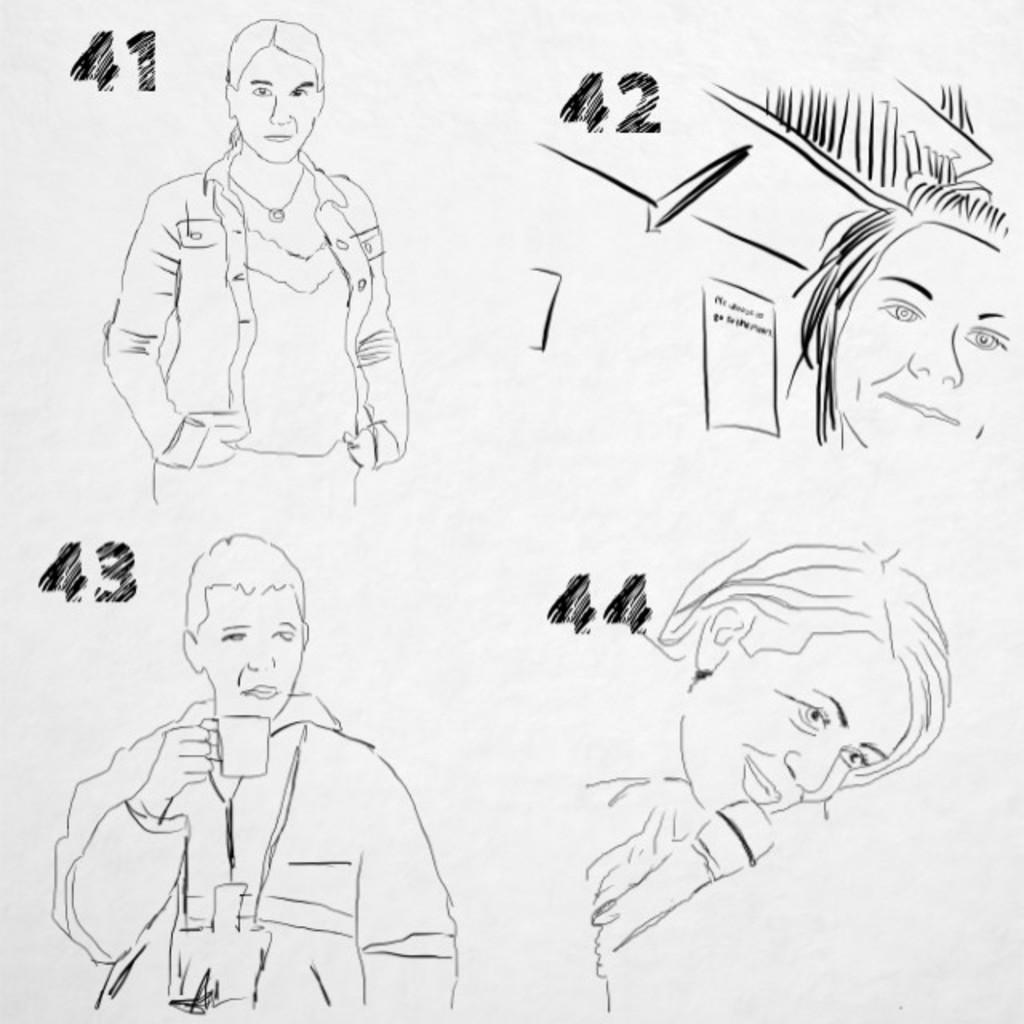What is the main subject of the image? There is a drawing in the image. What can be seen in the drawing? The drawing contains images of persons. Can you describe a specific action being performed by one of the persons in the drawing? There is a person holding a cup in the drawing. What type of symbols are present in the drawing? Numbers are present in the drawing. How many eyes does the person holding the cup have in the drawing? The provided facts do not mention the number of eyes or any other facial features of the person holding the cup in the drawing. 